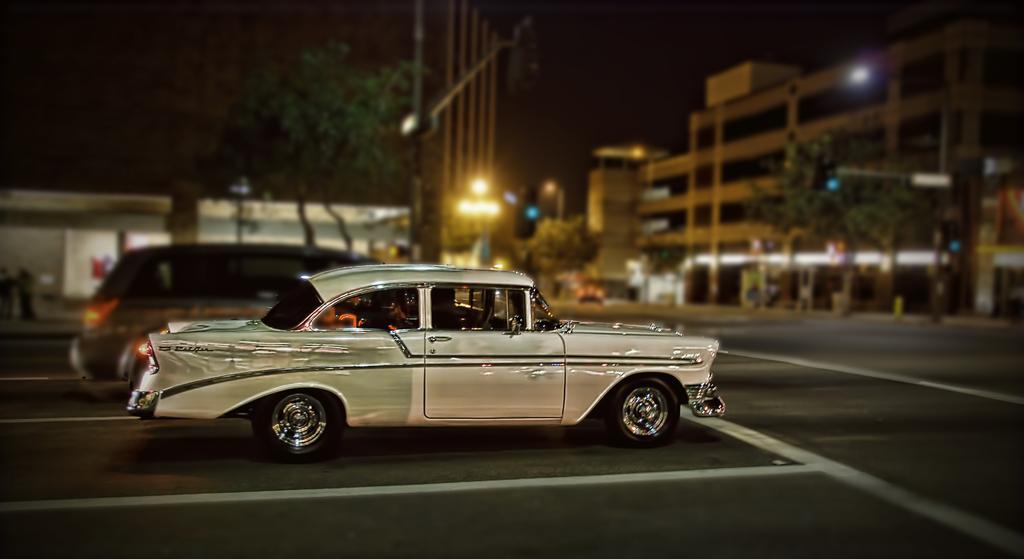Describe this image in one or two sentences. In this picture I can see vehicles on the road, there are buildings, lights, poles and trees. 